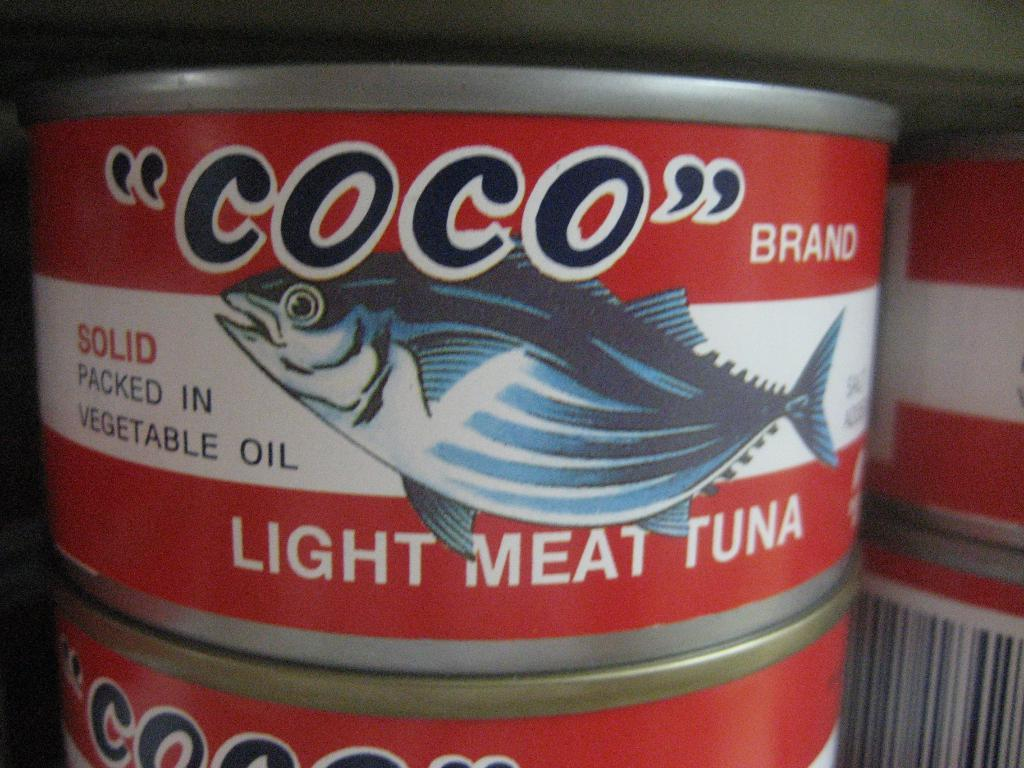<image>
Present a compact description of the photo's key features. A red and white can of Coco brand light meat tuna 